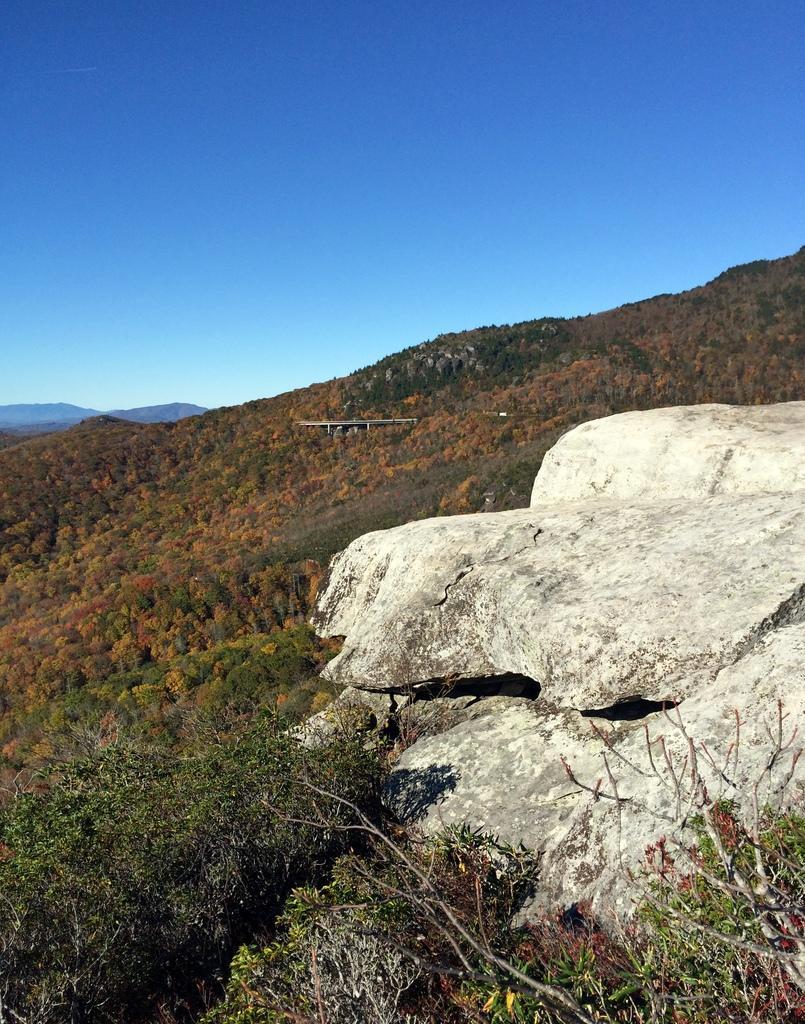In one or two sentences, can you explain what this image depicts? In this picture we can see rock and trees. In the background of the image we can see sky in blue color. 